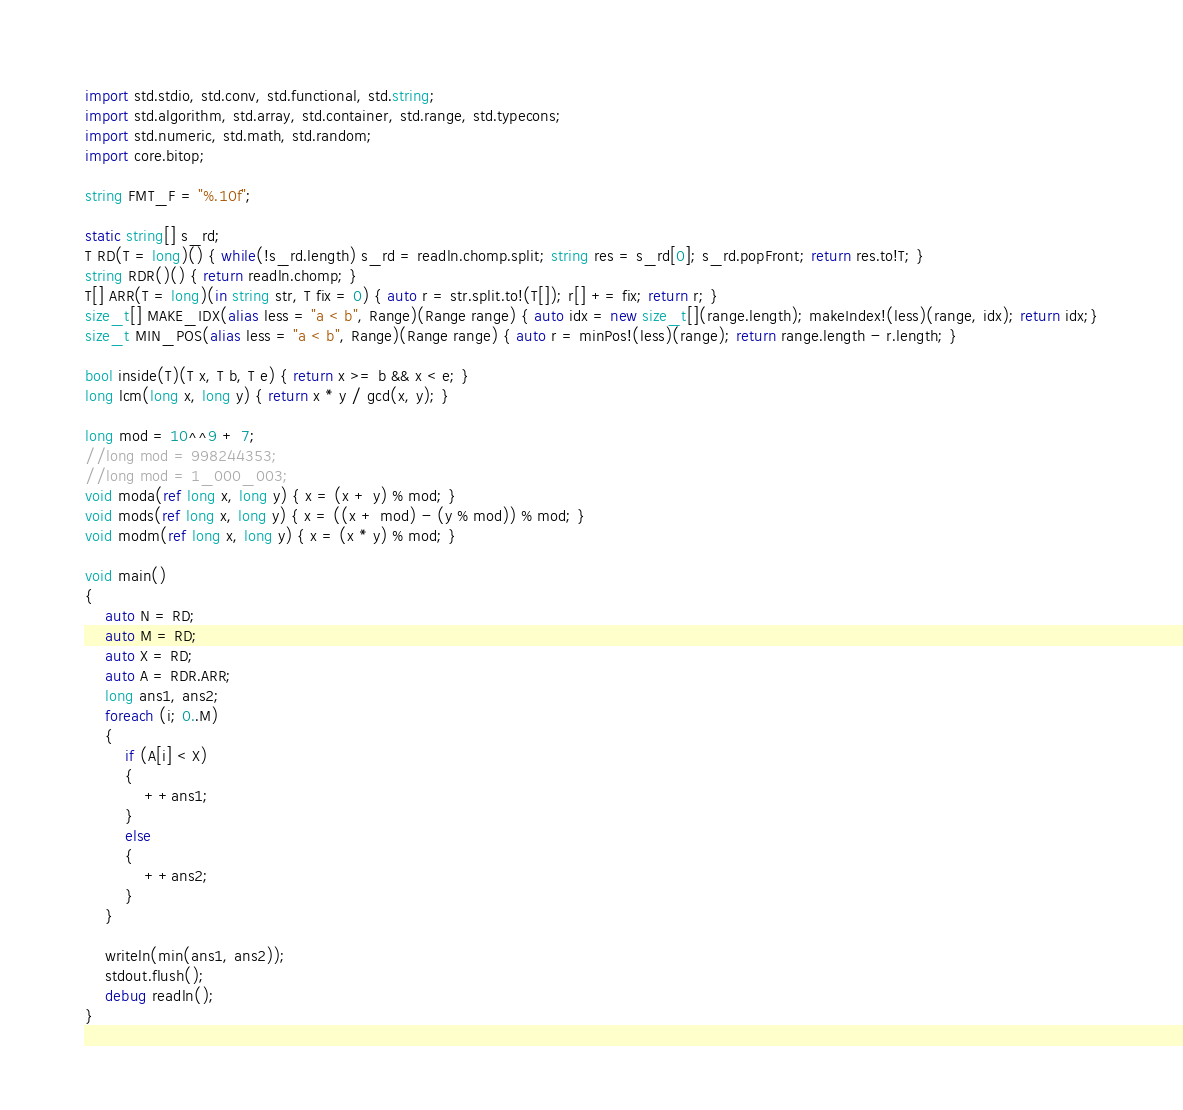<code> <loc_0><loc_0><loc_500><loc_500><_D_>import std.stdio, std.conv, std.functional, std.string;
import std.algorithm, std.array, std.container, std.range, std.typecons;
import std.numeric, std.math, std.random;
import core.bitop;

string FMT_F = "%.10f";

static string[] s_rd;
T RD(T = long)() { while(!s_rd.length) s_rd = readln.chomp.split; string res = s_rd[0]; s_rd.popFront; return res.to!T; }
string RDR()() { return readln.chomp; }
T[] ARR(T = long)(in string str, T fix = 0) { auto r = str.split.to!(T[]); r[] += fix; return r; }
size_t[] MAKE_IDX(alias less = "a < b", Range)(Range range) { auto idx = new size_t[](range.length); makeIndex!(less)(range, idx); return idx;}
size_t MIN_POS(alias less = "a < b", Range)(Range range) { auto r = minPos!(less)(range); return range.length - r.length; }

bool inside(T)(T x, T b, T e) { return x >= b && x < e; }
long lcm(long x, long y) { return x * y / gcd(x, y); }

long mod = 10^^9 + 7;
//long mod = 998244353;
//long mod = 1_000_003;
void moda(ref long x, long y) { x = (x + y) % mod; }
void mods(ref long x, long y) { x = ((x + mod) - (y % mod)) % mod; }
void modm(ref long x, long y) { x = (x * y) % mod; }

void main()
{
	auto N = RD;
	auto M = RD;
	auto X = RD;
	auto A = RDR.ARR;
	long ans1, ans2;
	foreach (i; 0..M)
	{
		if (A[i] < X)
		{
			++ans1;
		}
		else
		{
			++ans2;
		}
	}

	writeln(min(ans1, ans2));
	stdout.flush();
	debug readln();
}
</code> 